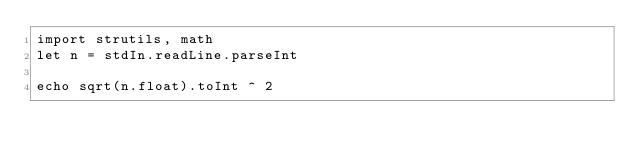<code> <loc_0><loc_0><loc_500><loc_500><_Nim_>import strutils, math
let n = stdIn.readLine.parseInt

echo sqrt(n.float).toInt ^ 2
</code> 